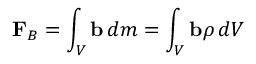<formula> <loc_0><loc_0><loc_500><loc_500>F _ { B } = \int _ { V } b \, d m = \int _ { V } b \rho \, d V</formula> 